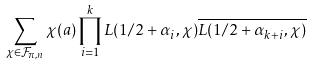<formula> <loc_0><loc_0><loc_500><loc_500>\sum _ { \chi \in \mathcal { F } _ { \pi , n } } \chi ( a ) \prod _ { i = 1 } ^ { k } L ( 1 / 2 + \alpha _ { i } , \chi ) \overline { L ( 1 / 2 + \alpha _ { k + i } , \chi ) }</formula> 